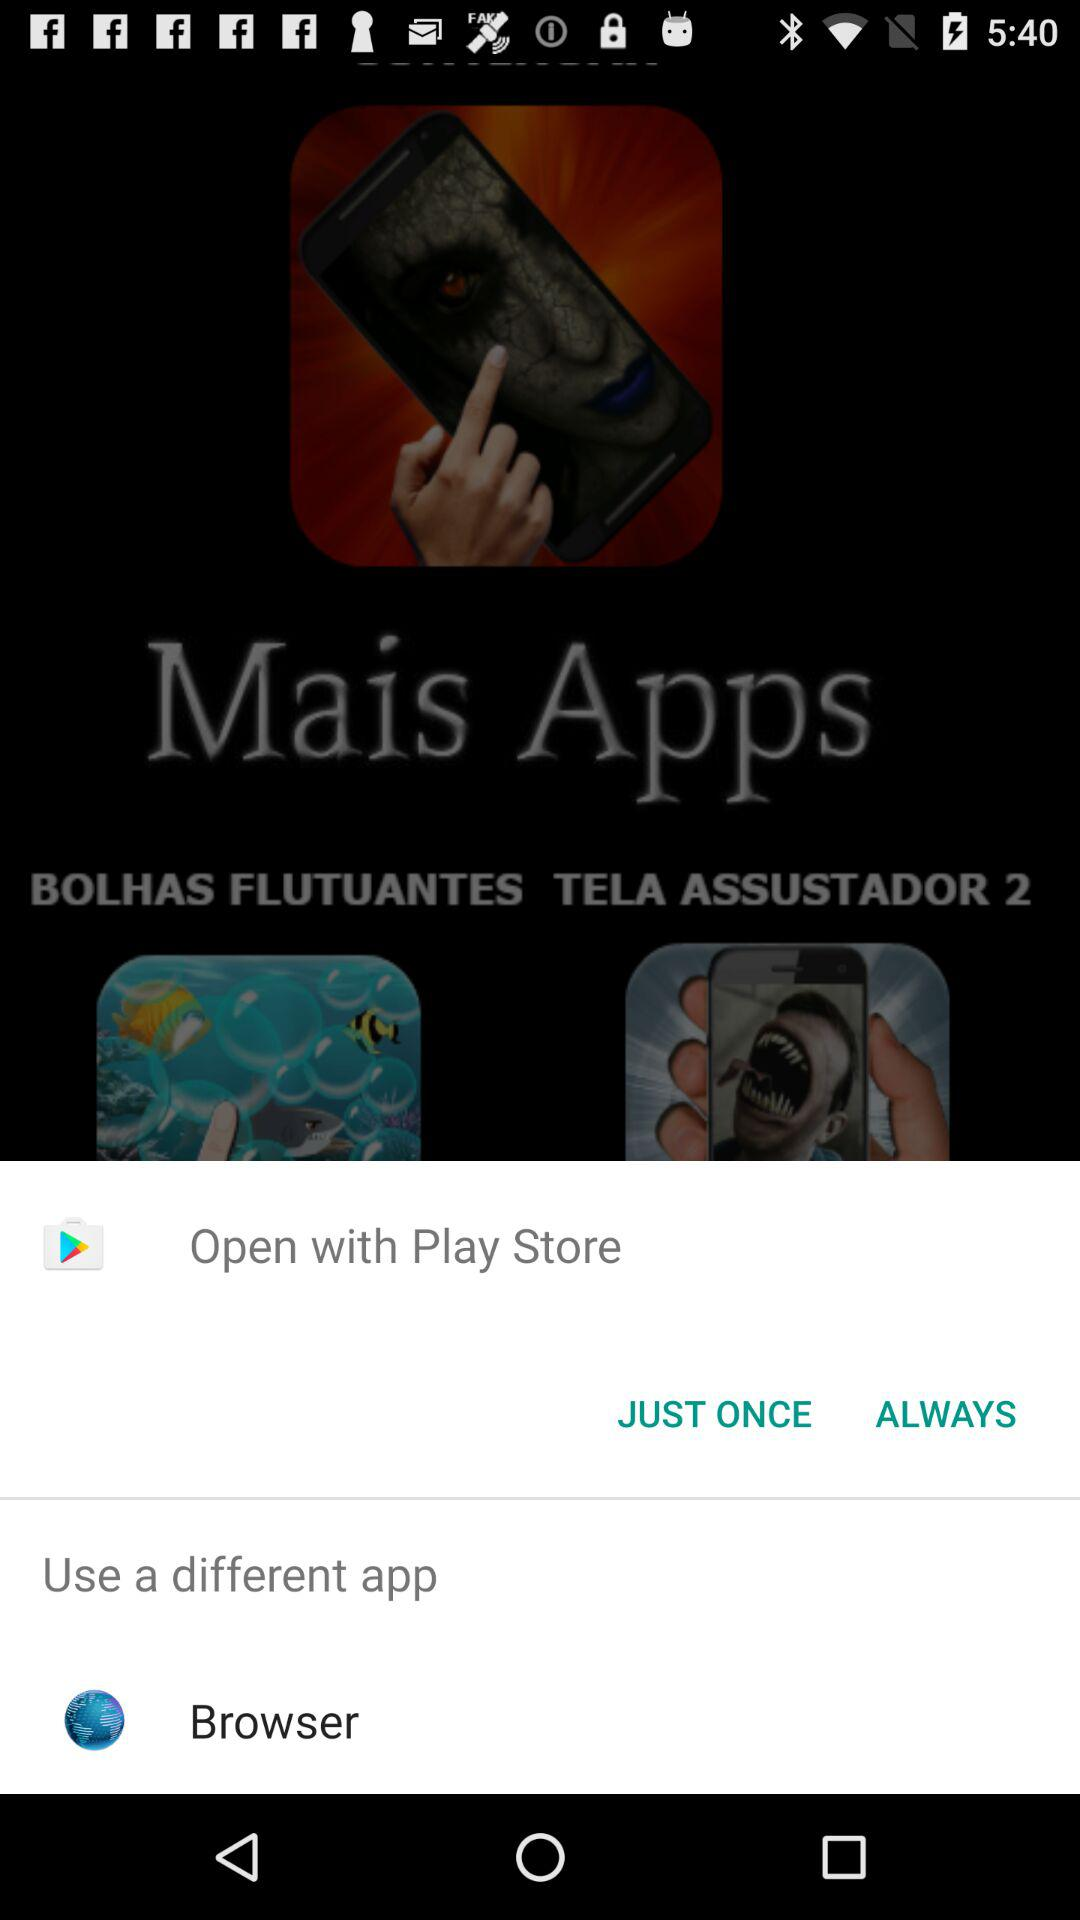What is the name of the application? The names of the applications are "BOLHAS FLUTUANTES" and "TELA ASSUSTADOR 2". 